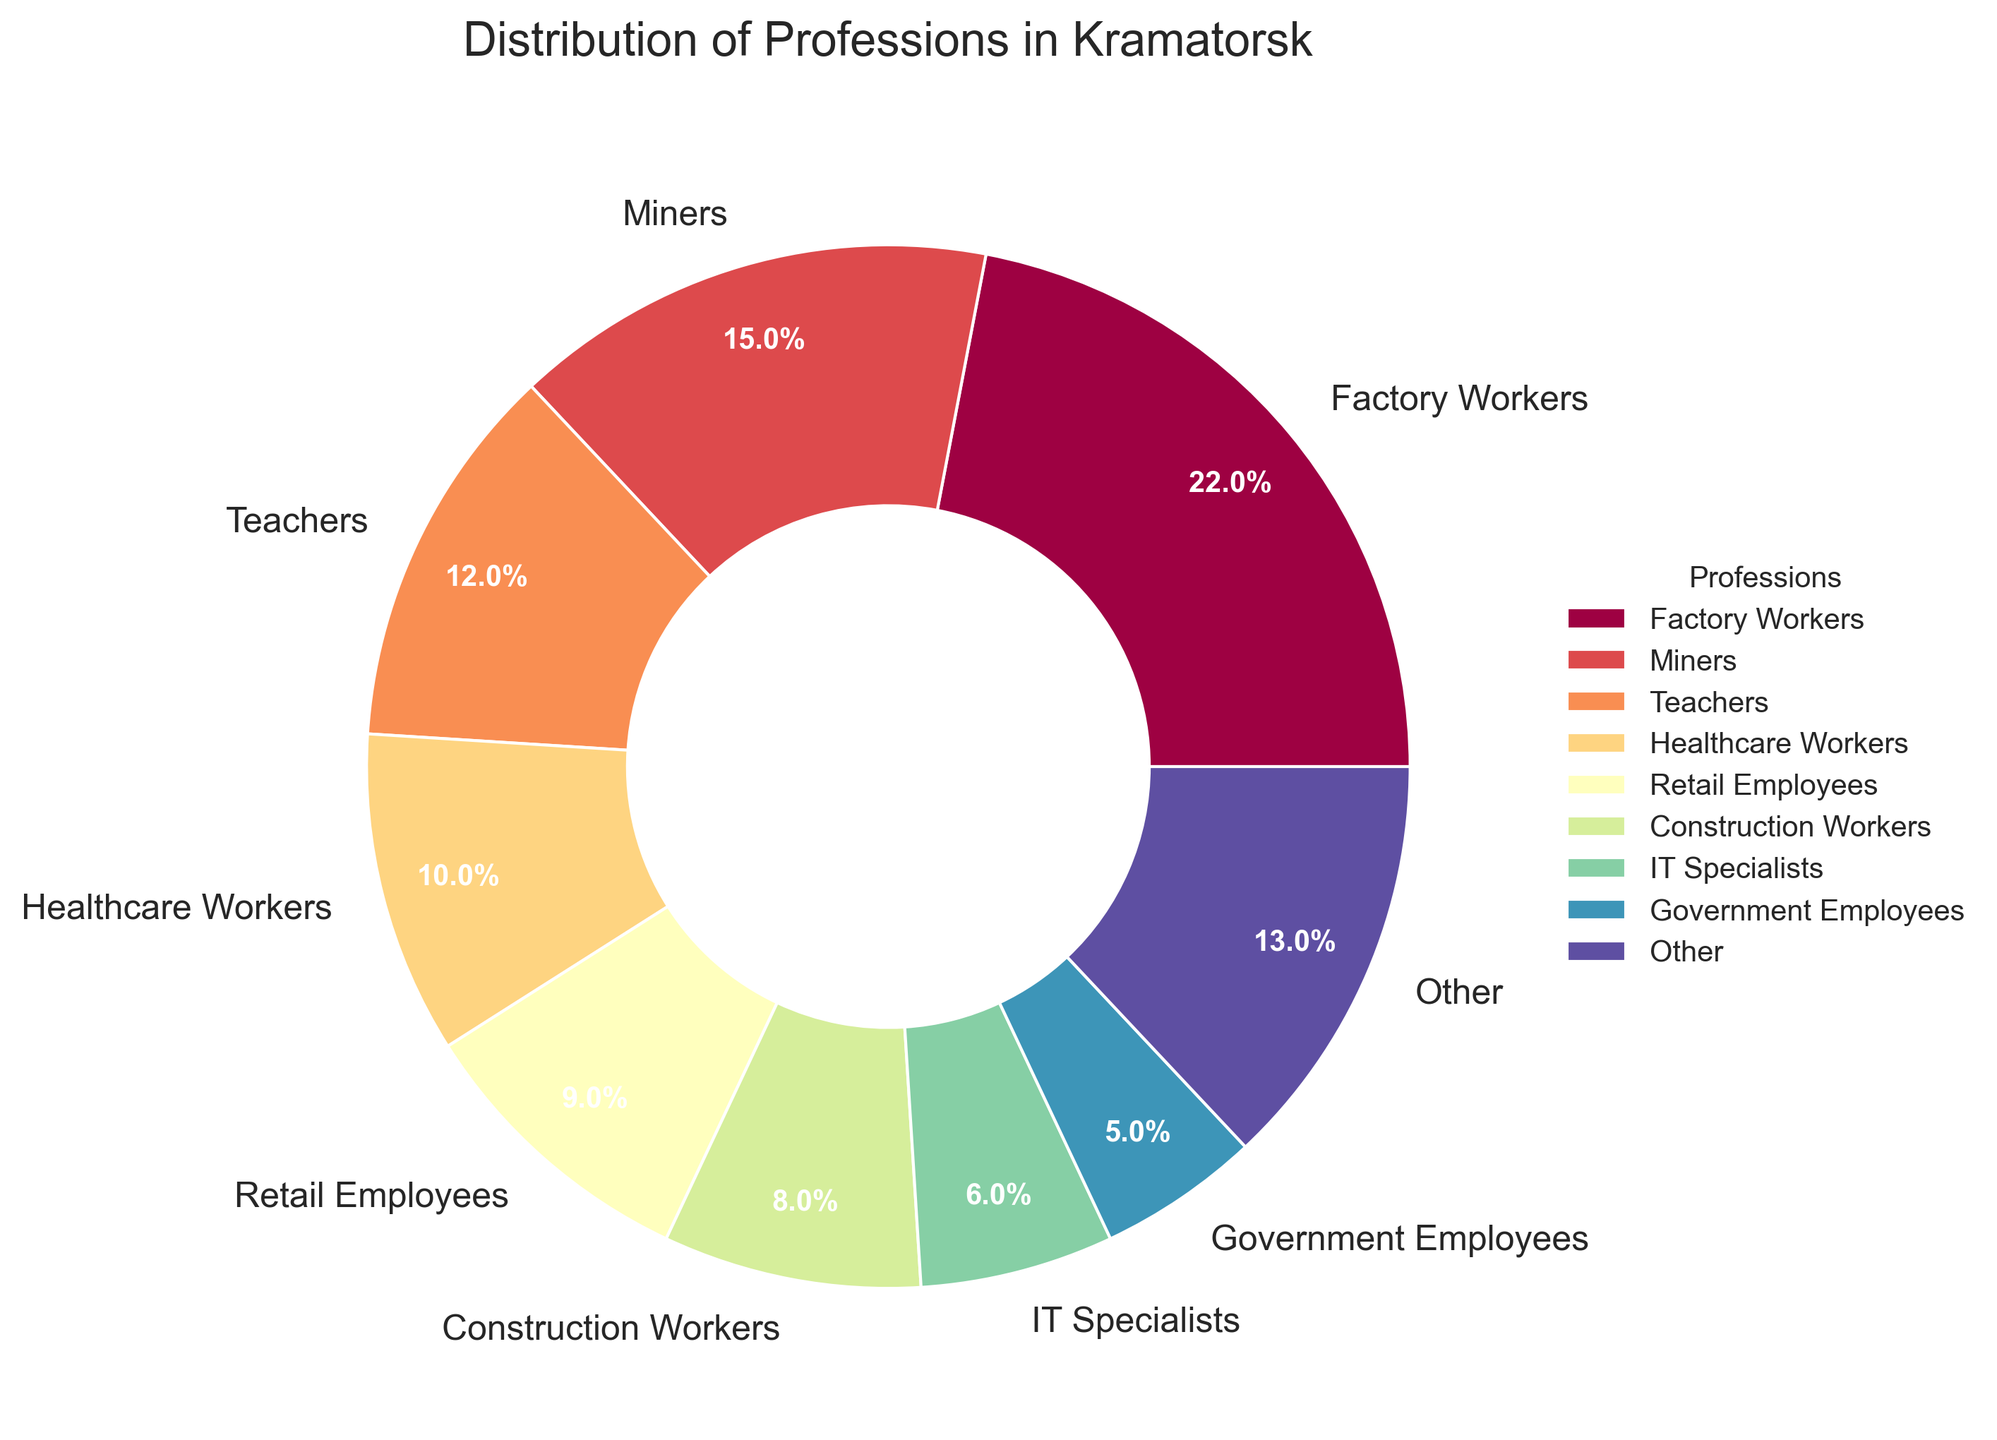What are the three most common professions in Kramatorsk? To find the three most common professions, look at the largest slices of the pie chart. The largest slice represents Factory Workers, followed by Miners, and then Teachers.
Answer: Factory Workers, Miners, Teachers What percentage of the working-age residents works in IT? Look at the pie chart and find the slice labeled "IT Specialists". The text on that slice indicates that IT Specialists constitute 6% of the working-age residents.
Answer: 6% Which profession has a higher percentage: Healthcare Workers or Retail Employees? Compare the two slices labeled "Healthcare Workers" and "Retail Employees". The Healthcare Workers slice shows 10%, while the Retail Employees slice shows 9%.
Answer: Healthcare Workers What is the combined percentage of Teachers and Government Employees? Find the percentage of Teachers (12%) and add it to the percentage of Government Employees (5%). Add the two values together: 12% + 5% = 17%.
Answer: 17% How much larger is the percentage of Factory Workers compared to Transportation Workers? The percentage of Factory Workers is 22%, and the percentage of Transportation Workers is 2%. Subtract the smaller percentage from the larger one: 22% - 2% = 20%.
Answer: 20% What percentage of professions is grouped under "Other"? Look for the slice labeled "Other". The text on that slice shows the percentage for all grouped smaller professions together.
Answer: 13% Which slice is larger: Construction Workers or Service Industry Workers? Compare the size of the slices labeled "Construction Workers" and "Service Industry Workers". The Construction Workers slice is 8%, whereas the Service Industry Workers slice is 4%.
Answer: Construction Workers Between Military Personnel and Financial Services, which profession has fewer working-age residents? Look for the slices labeled "Military Personnel" and "Financial Services". Both have small slices, each taking up 1% of the chart. Since both are equal in this case, neither has fewer working-age residents.
Answer: Equal at 1% each 